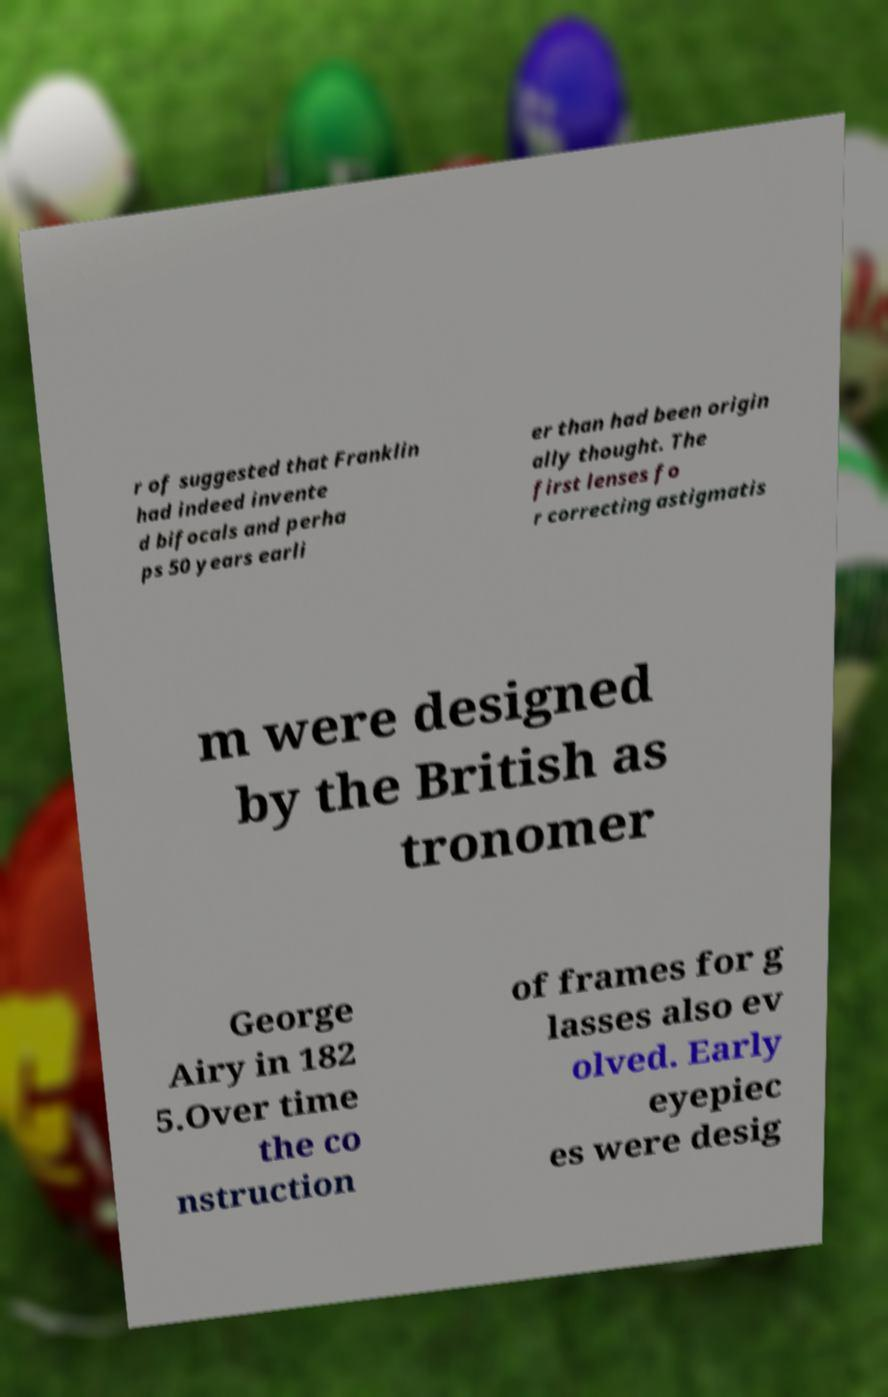What messages or text are displayed in this image? I need them in a readable, typed format. r of suggested that Franklin had indeed invente d bifocals and perha ps 50 years earli er than had been origin ally thought. The first lenses fo r correcting astigmatis m were designed by the British as tronomer George Airy in 182 5.Over time the co nstruction of frames for g lasses also ev olved. Early eyepiec es were desig 